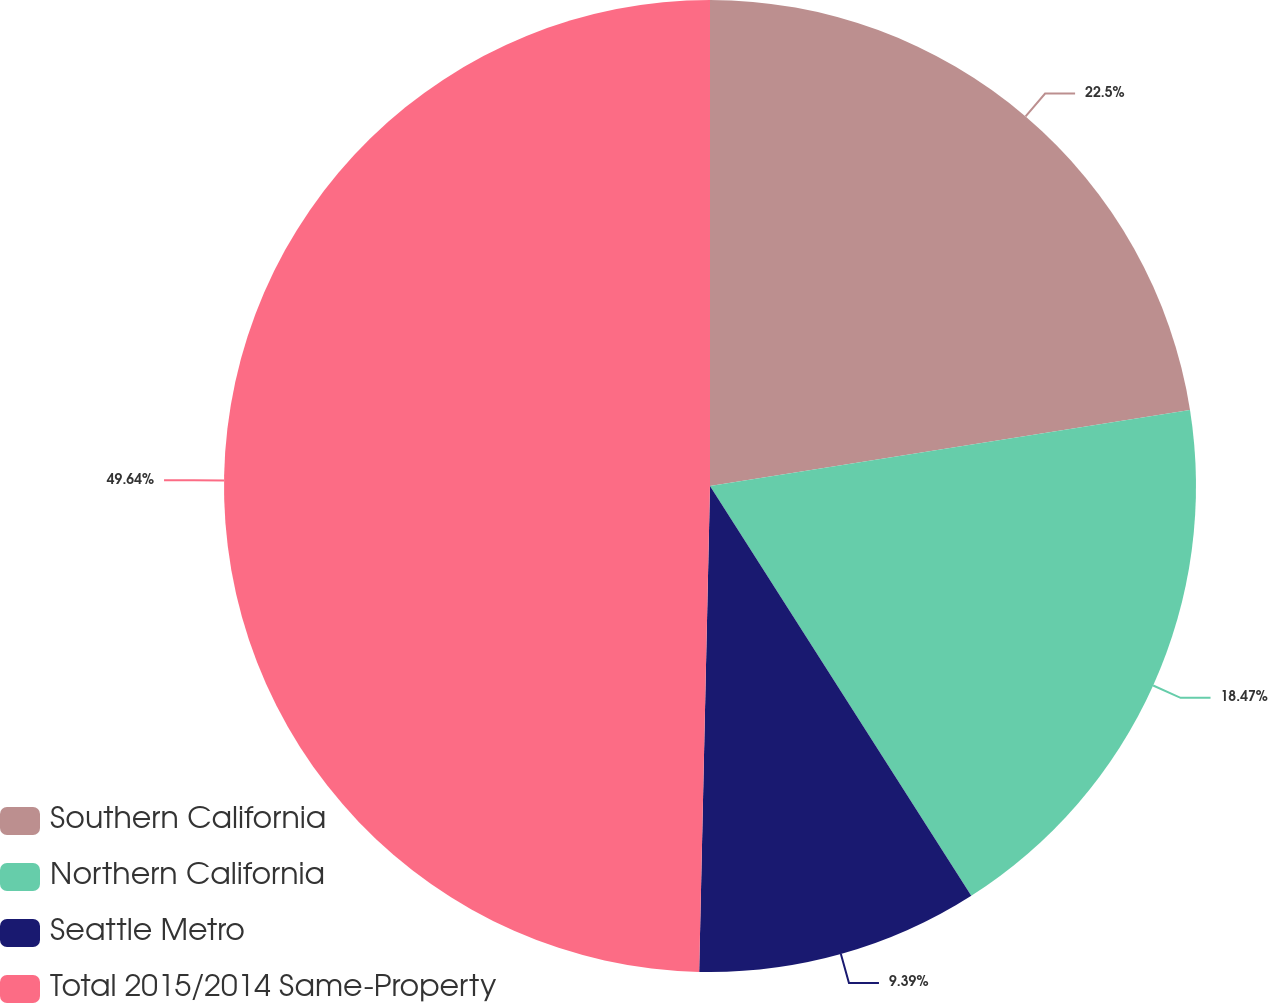<chart> <loc_0><loc_0><loc_500><loc_500><pie_chart><fcel>Southern California<fcel>Northern California<fcel>Seattle Metro<fcel>Total 2015/2014 Same-Property<nl><fcel>22.5%<fcel>18.47%<fcel>9.39%<fcel>49.65%<nl></chart> 